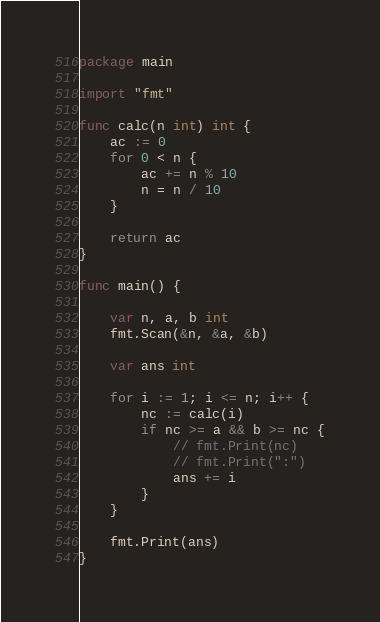<code> <loc_0><loc_0><loc_500><loc_500><_Go_>package main

import "fmt"

func calc(n int) int {
	ac := 0
	for 0 < n {
		ac += n % 10
		n = n / 10
	}

	return ac
}

func main() {

	var n, a, b int
	fmt.Scan(&n, &a, &b)

	var ans int

	for i := 1; i <= n; i++ {
		nc := calc(i)
		if nc >= a && b >= nc {
			// fmt.Print(nc)
			// fmt.Print(":")
			ans += i
		}
	}

	fmt.Print(ans)
}</code> 